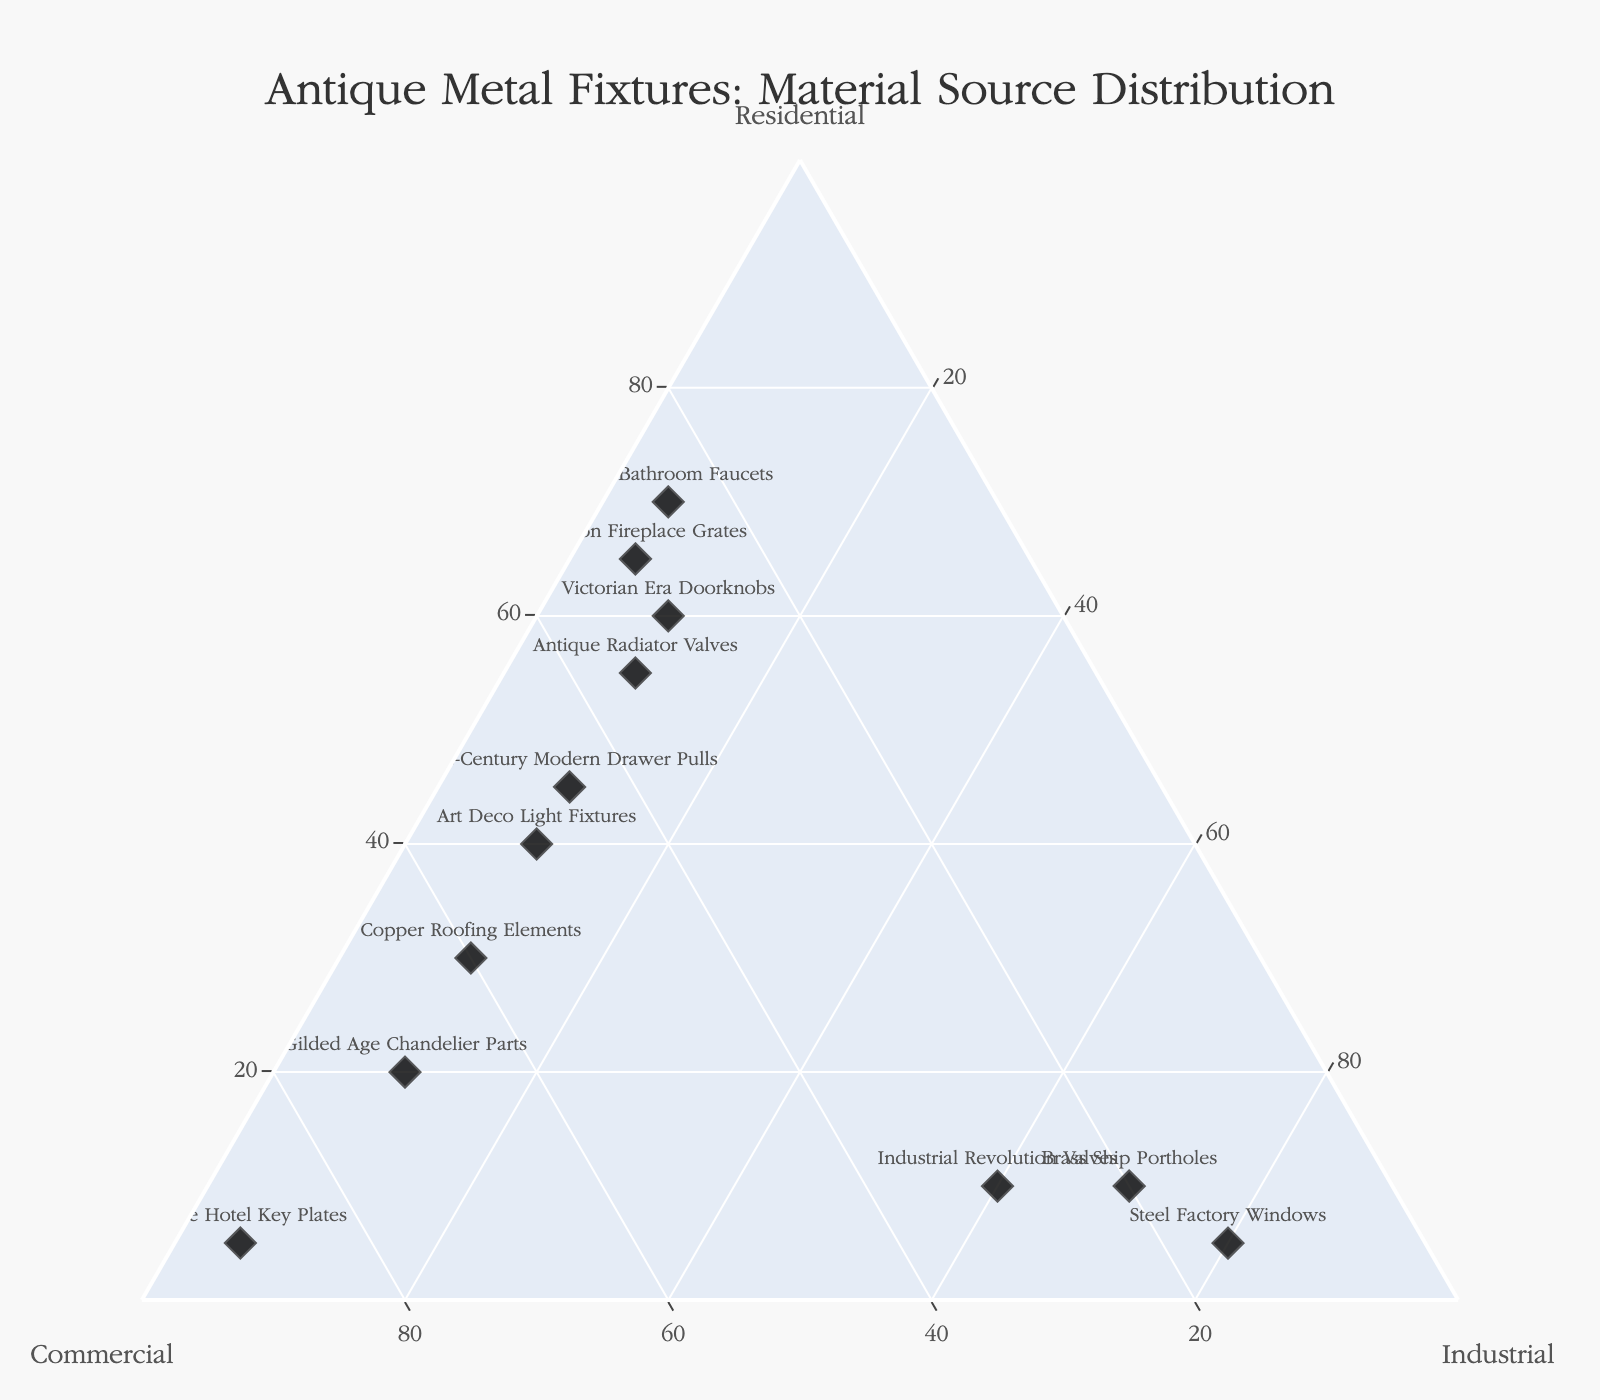What's the title of the figure? The title can be found at the top of the figure. It provides a brief description of what the figure represents.
Answer: Antique Metal Fixtures: Material Source Distribution How many data points are shown in the figure? Count the number of different sources listed in the figure.
Answer: 12 Which material source is dominantly from commercial buildings? Look for the point closest to the Commercial axis. This point will have the highest commercial proportion.
Answer: Vintage Hotel Key Plates What is the sum of residential proportions for Victorian Era Doorknobs and 1920s Bathroom Faucets? Add the residential proportions for both sources: 60 (Victorian Era Doorknobs) + 70 (1920s Bathroom Faucets).
Answer: 130 Which source has the smallest industrial proportion? Find the point closest to the Residential-Commercial edge, representing a low industrial proportion.
Answer: Cast Iron Fireplace Grates Compare the residential proportion of Art Deco Light Fixtures and Mid-Century Modern Drawer Pulls. Which one is higher? Compare the residential values of both data points: 40 (Art Deco Light Fixtures) vs 45 (Mid-Century Modern Drawer Pulls).
Answer: Mid-Century Modern Drawer Pulls What is the average commercial proportion across all sources? Sum up all commercial proportions and divide by the number of sources: (30+50+30+25+45+70+35+30+90+15+20+60) / 12.
Answer: 40 Identify sources with the same proportion for any two categories. Look for points where any two axis values are the same: Mid-Century Modern Drawer Pulls (Residential and Commercial both 45).
Answer: Mid-Century Modern Drawer Pulls Which source exhibits a balanced distribution among the three material sources? Look for the points that are central in the ternary plot, indicating a more balanced distribution.
Answer: Art Deco Light Fixtures 